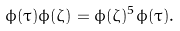Convert formula to latex. <formula><loc_0><loc_0><loc_500><loc_500>\phi ( \tau ) \phi ( \zeta ) = \phi ( \zeta ) ^ { 5 } \phi ( \tau ) .</formula> 